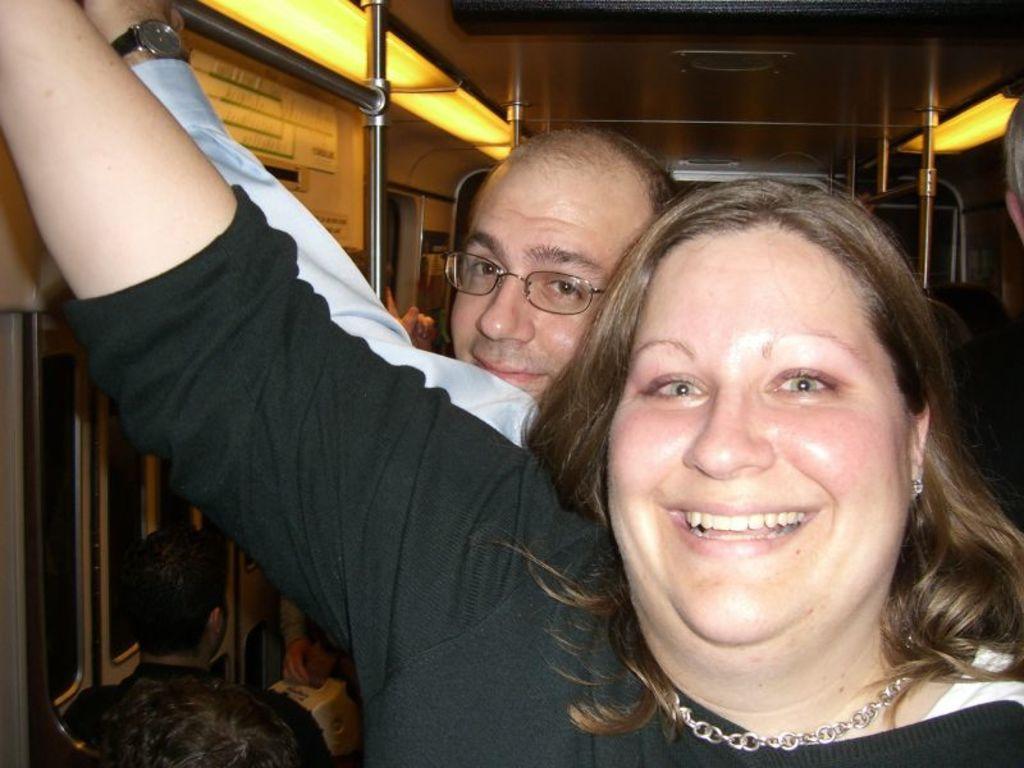Describe this image in one or two sentences. In this image two people were standing by holding the metal rod. Beside them people were sitting on the chair in the train. 